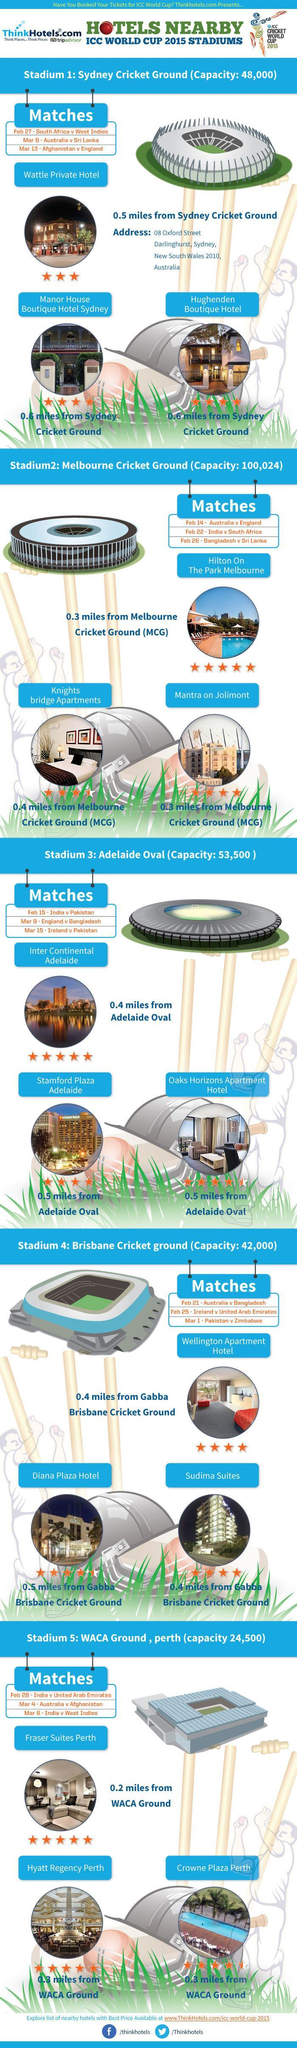How many hotels have a 4-star rating?
Answer the question with a short phrase. 6 Which stadium has the highest capacity-stadium 1, stadium 2, stadium 3, stadium 4? stadium 2 How many hotels have a 5-star rating? 4 Which hotel is close to Sydney cricket ground-Hughenden boutique hotel or Wattle private hotel? Wattle private hotel Which hotel is close to Melbourne cricket ground-Knights Bridge apartments or Mantra on Jolimont? Mantra on Jolimont How many hotels have a 3-star rating? 1 